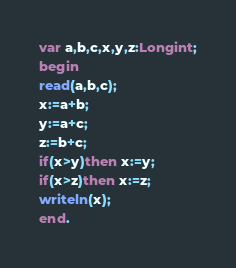<code> <loc_0><loc_0><loc_500><loc_500><_Pascal_>var a,b,c,x,y,z:Longint;
begin
read(a,b,c);
x:=a+b;
y:=a+c;
z:=b+c;
if(x>y)then x:=y;
if(x>z)then x:=z;
writeln(x);
end.</code> 